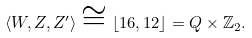Convert formula to latex. <formula><loc_0><loc_0><loc_500><loc_500>\left \langle W , Z , Z ^ { \prime } \right \rangle \cong \left \lfloor 1 6 , 1 2 \right \rfloor = Q \times \mathbb { Z } _ { 2 } .</formula> 